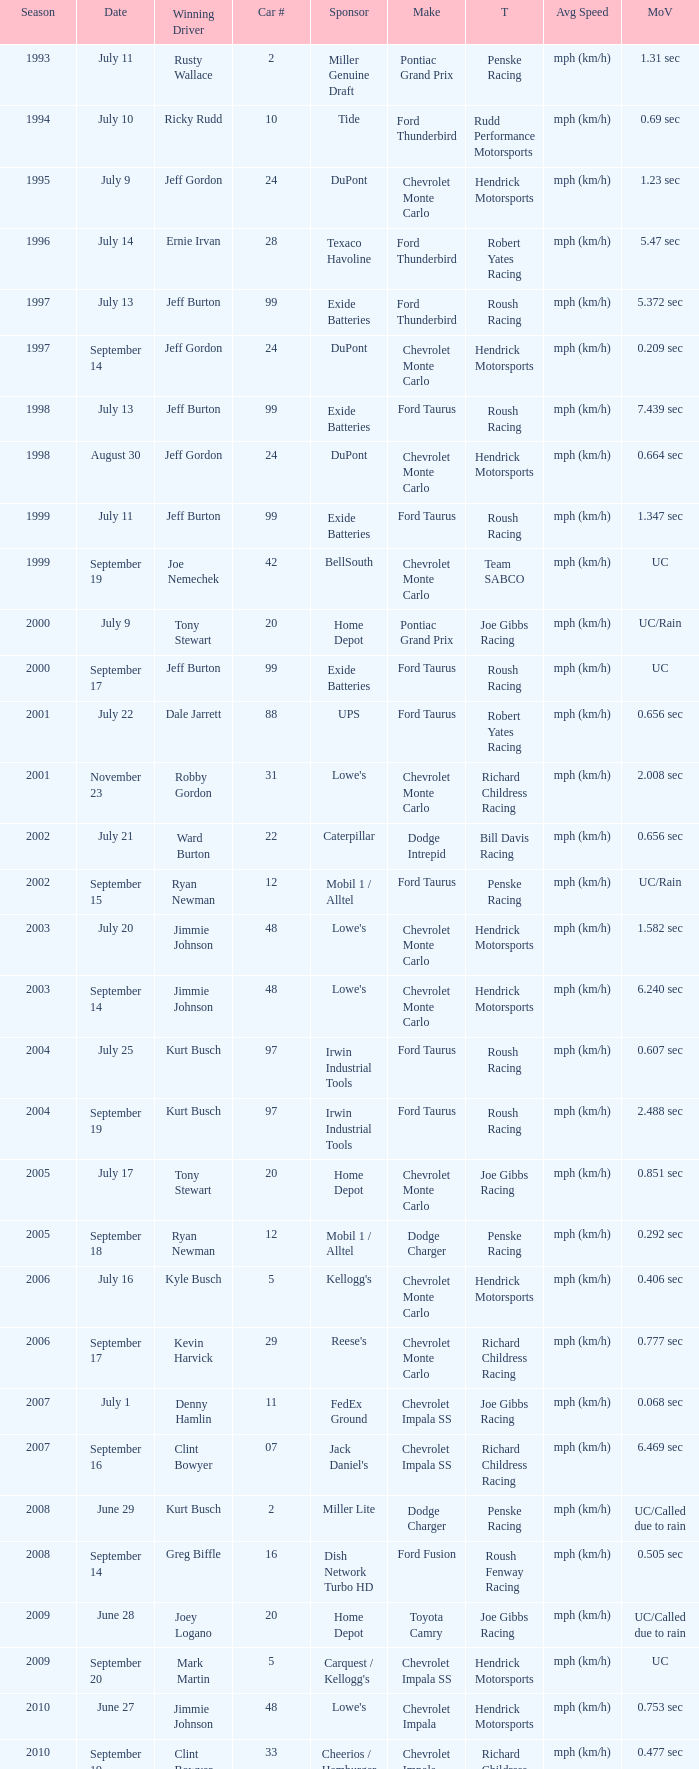What was the average speed of Tony Stewart's winning Chevrolet Impala? Mph (km/h). 